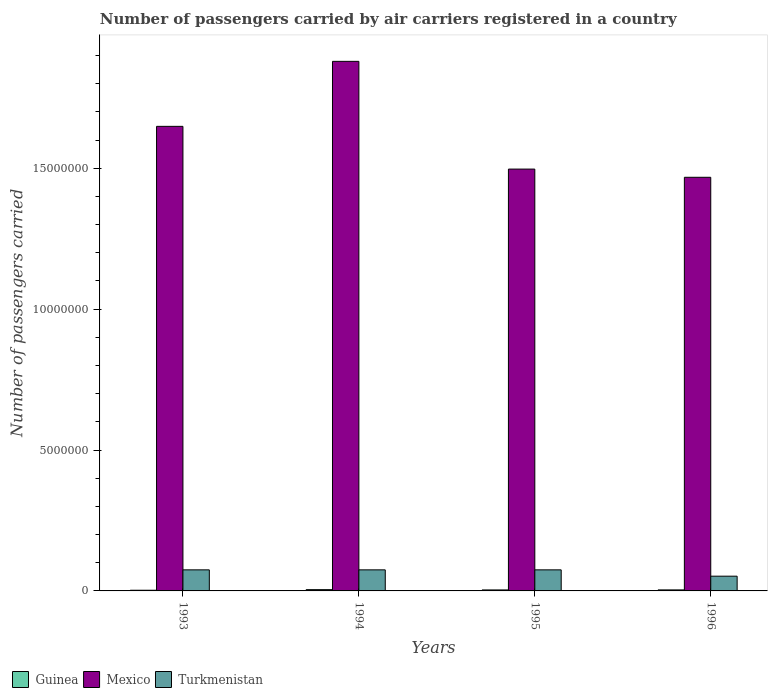Are the number of bars per tick equal to the number of legend labels?
Make the answer very short. Yes. How many bars are there on the 2nd tick from the right?
Offer a very short reply. 3. What is the label of the 3rd group of bars from the left?
Your answer should be very brief. 1995. In how many cases, is the number of bars for a given year not equal to the number of legend labels?
Your answer should be very brief. 0. What is the number of passengers carried by air carriers in Turkmenistan in 1995?
Offer a terse response. 7.48e+05. Across all years, what is the maximum number of passengers carried by air carriers in Guinea?
Your response must be concise. 4.50e+04. Across all years, what is the minimum number of passengers carried by air carriers in Turkmenistan?
Make the answer very short. 5.23e+05. In which year was the number of passengers carried by air carriers in Guinea minimum?
Offer a very short reply. 1993. What is the total number of passengers carried by air carriers in Turkmenistan in the graph?
Offer a terse response. 2.77e+06. What is the difference between the number of passengers carried by air carriers in Guinea in 1993 and that in 1995?
Your answer should be compact. -1.08e+04. What is the difference between the number of passengers carried by air carriers in Mexico in 1993 and the number of passengers carried by air carriers in Turkmenistan in 1995?
Your response must be concise. 1.57e+07. What is the average number of passengers carried by air carriers in Turkmenistan per year?
Keep it short and to the point. 6.92e+05. In the year 1996, what is the difference between the number of passengers carried by air carriers in Mexico and number of passengers carried by air carriers in Turkmenistan?
Your answer should be compact. 1.42e+07. In how many years, is the number of passengers carried by air carriers in Turkmenistan greater than 4000000?
Make the answer very short. 0. What is the ratio of the number of passengers carried by air carriers in Guinea in 1993 to that in 1995?
Offer a very short reply. 0.69. What is the difference between the highest and the second highest number of passengers carried by air carriers in Guinea?
Make the answer very short. 8700. What is the difference between the highest and the lowest number of passengers carried by air carriers in Mexico?
Provide a short and direct response. 4.11e+06. Is the sum of the number of passengers carried by air carriers in Turkmenistan in 1994 and 1996 greater than the maximum number of passengers carried by air carriers in Mexico across all years?
Provide a short and direct response. No. What does the 3rd bar from the left in 1996 represents?
Provide a succinct answer. Turkmenistan. What does the 2nd bar from the right in 1996 represents?
Make the answer very short. Mexico. How many bars are there?
Your answer should be very brief. 12. Are all the bars in the graph horizontal?
Keep it short and to the point. No. How many years are there in the graph?
Keep it short and to the point. 4. What is the difference between two consecutive major ticks on the Y-axis?
Your response must be concise. 5.00e+06. Does the graph contain any zero values?
Provide a short and direct response. No. Does the graph contain grids?
Ensure brevity in your answer.  No. How many legend labels are there?
Your response must be concise. 3. How are the legend labels stacked?
Your response must be concise. Horizontal. What is the title of the graph?
Give a very brief answer. Number of passengers carried by air carriers registered in a country. What is the label or title of the Y-axis?
Ensure brevity in your answer.  Number of passengers carried. What is the Number of passengers carried of Guinea in 1993?
Ensure brevity in your answer.  2.42e+04. What is the Number of passengers carried in Mexico in 1993?
Provide a short and direct response. 1.65e+07. What is the Number of passengers carried in Turkmenistan in 1993?
Give a very brief answer. 7.48e+05. What is the Number of passengers carried of Guinea in 1994?
Your answer should be very brief. 4.50e+04. What is the Number of passengers carried in Mexico in 1994?
Your answer should be compact. 1.88e+07. What is the Number of passengers carried of Turkmenistan in 1994?
Provide a short and direct response. 7.48e+05. What is the Number of passengers carried in Guinea in 1995?
Ensure brevity in your answer.  3.50e+04. What is the Number of passengers carried of Mexico in 1995?
Offer a very short reply. 1.50e+07. What is the Number of passengers carried of Turkmenistan in 1995?
Provide a succinct answer. 7.48e+05. What is the Number of passengers carried in Guinea in 1996?
Ensure brevity in your answer.  3.63e+04. What is the Number of passengers carried in Mexico in 1996?
Ensure brevity in your answer.  1.47e+07. What is the Number of passengers carried of Turkmenistan in 1996?
Your answer should be compact. 5.23e+05. Across all years, what is the maximum Number of passengers carried of Guinea?
Provide a succinct answer. 4.50e+04. Across all years, what is the maximum Number of passengers carried in Mexico?
Keep it short and to the point. 1.88e+07. Across all years, what is the maximum Number of passengers carried of Turkmenistan?
Your answer should be compact. 7.48e+05. Across all years, what is the minimum Number of passengers carried in Guinea?
Make the answer very short. 2.42e+04. Across all years, what is the minimum Number of passengers carried of Mexico?
Provide a short and direct response. 1.47e+07. Across all years, what is the minimum Number of passengers carried in Turkmenistan?
Provide a succinct answer. 5.23e+05. What is the total Number of passengers carried of Guinea in the graph?
Provide a short and direct response. 1.40e+05. What is the total Number of passengers carried of Mexico in the graph?
Give a very brief answer. 6.49e+07. What is the total Number of passengers carried of Turkmenistan in the graph?
Your answer should be compact. 2.77e+06. What is the difference between the Number of passengers carried in Guinea in 1993 and that in 1994?
Keep it short and to the point. -2.08e+04. What is the difference between the Number of passengers carried in Mexico in 1993 and that in 1994?
Offer a terse response. -2.31e+06. What is the difference between the Number of passengers carried in Turkmenistan in 1993 and that in 1994?
Provide a short and direct response. 0. What is the difference between the Number of passengers carried of Guinea in 1993 and that in 1995?
Offer a terse response. -1.08e+04. What is the difference between the Number of passengers carried of Mexico in 1993 and that in 1995?
Provide a succinct answer. 1.52e+06. What is the difference between the Number of passengers carried in Guinea in 1993 and that in 1996?
Ensure brevity in your answer.  -1.21e+04. What is the difference between the Number of passengers carried in Mexico in 1993 and that in 1996?
Provide a short and direct response. 1.81e+06. What is the difference between the Number of passengers carried of Turkmenistan in 1993 and that in 1996?
Give a very brief answer. 2.25e+05. What is the difference between the Number of passengers carried of Guinea in 1994 and that in 1995?
Your answer should be compact. 10000. What is the difference between the Number of passengers carried of Mexico in 1994 and that in 1995?
Offer a very short reply. 3.82e+06. What is the difference between the Number of passengers carried of Turkmenistan in 1994 and that in 1995?
Give a very brief answer. 0. What is the difference between the Number of passengers carried of Guinea in 1994 and that in 1996?
Your answer should be compact. 8700. What is the difference between the Number of passengers carried in Mexico in 1994 and that in 1996?
Your answer should be compact. 4.11e+06. What is the difference between the Number of passengers carried of Turkmenistan in 1994 and that in 1996?
Your answer should be compact. 2.25e+05. What is the difference between the Number of passengers carried of Guinea in 1995 and that in 1996?
Offer a terse response. -1300. What is the difference between the Number of passengers carried in Mexico in 1995 and that in 1996?
Offer a very short reply. 2.91e+05. What is the difference between the Number of passengers carried in Turkmenistan in 1995 and that in 1996?
Ensure brevity in your answer.  2.25e+05. What is the difference between the Number of passengers carried in Guinea in 1993 and the Number of passengers carried in Mexico in 1994?
Offer a very short reply. -1.88e+07. What is the difference between the Number of passengers carried in Guinea in 1993 and the Number of passengers carried in Turkmenistan in 1994?
Offer a terse response. -7.24e+05. What is the difference between the Number of passengers carried in Mexico in 1993 and the Number of passengers carried in Turkmenistan in 1994?
Offer a terse response. 1.57e+07. What is the difference between the Number of passengers carried in Guinea in 1993 and the Number of passengers carried in Mexico in 1995?
Offer a terse response. -1.49e+07. What is the difference between the Number of passengers carried in Guinea in 1993 and the Number of passengers carried in Turkmenistan in 1995?
Ensure brevity in your answer.  -7.24e+05. What is the difference between the Number of passengers carried of Mexico in 1993 and the Number of passengers carried of Turkmenistan in 1995?
Keep it short and to the point. 1.57e+07. What is the difference between the Number of passengers carried of Guinea in 1993 and the Number of passengers carried of Mexico in 1996?
Make the answer very short. -1.47e+07. What is the difference between the Number of passengers carried in Guinea in 1993 and the Number of passengers carried in Turkmenistan in 1996?
Your answer should be very brief. -4.99e+05. What is the difference between the Number of passengers carried in Mexico in 1993 and the Number of passengers carried in Turkmenistan in 1996?
Give a very brief answer. 1.60e+07. What is the difference between the Number of passengers carried in Guinea in 1994 and the Number of passengers carried in Mexico in 1995?
Your response must be concise. -1.49e+07. What is the difference between the Number of passengers carried in Guinea in 1994 and the Number of passengers carried in Turkmenistan in 1995?
Give a very brief answer. -7.03e+05. What is the difference between the Number of passengers carried of Mexico in 1994 and the Number of passengers carried of Turkmenistan in 1995?
Offer a very short reply. 1.80e+07. What is the difference between the Number of passengers carried of Guinea in 1994 and the Number of passengers carried of Mexico in 1996?
Ensure brevity in your answer.  -1.46e+07. What is the difference between the Number of passengers carried in Guinea in 1994 and the Number of passengers carried in Turkmenistan in 1996?
Make the answer very short. -4.78e+05. What is the difference between the Number of passengers carried of Mexico in 1994 and the Number of passengers carried of Turkmenistan in 1996?
Provide a succinct answer. 1.83e+07. What is the difference between the Number of passengers carried of Guinea in 1995 and the Number of passengers carried of Mexico in 1996?
Give a very brief answer. -1.46e+07. What is the difference between the Number of passengers carried of Guinea in 1995 and the Number of passengers carried of Turkmenistan in 1996?
Keep it short and to the point. -4.88e+05. What is the difference between the Number of passengers carried of Mexico in 1995 and the Number of passengers carried of Turkmenistan in 1996?
Your response must be concise. 1.44e+07. What is the average Number of passengers carried in Guinea per year?
Keep it short and to the point. 3.51e+04. What is the average Number of passengers carried of Mexico per year?
Offer a very short reply. 1.62e+07. What is the average Number of passengers carried in Turkmenistan per year?
Offer a very short reply. 6.92e+05. In the year 1993, what is the difference between the Number of passengers carried of Guinea and Number of passengers carried of Mexico?
Provide a short and direct response. -1.65e+07. In the year 1993, what is the difference between the Number of passengers carried in Guinea and Number of passengers carried in Turkmenistan?
Your response must be concise. -7.24e+05. In the year 1993, what is the difference between the Number of passengers carried of Mexico and Number of passengers carried of Turkmenistan?
Keep it short and to the point. 1.57e+07. In the year 1994, what is the difference between the Number of passengers carried in Guinea and Number of passengers carried in Mexico?
Provide a short and direct response. -1.87e+07. In the year 1994, what is the difference between the Number of passengers carried in Guinea and Number of passengers carried in Turkmenistan?
Ensure brevity in your answer.  -7.03e+05. In the year 1994, what is the difference between the Number of passengers carried in Mexico and Number of passengers carried in Turkmenistan?
Your answer should be very brief. 1.80e+07. In the year 1995, what is the difference between the Number of passengers carried of Guinea and Number of passengers carried of Mexico?
Ensure brevity in your answer.  -1.49e+07. In the year 1995, what is the difference between the Number of passengers carried of Guinea and Number of passengers carried of Turkmenistan?
Provide a succinct answer. -7.13e+05. In the year 1995, what is the difference between the Number of passengers carried in Mexico and Number of passengers carried in Turkmenistan?
Your answer should be very brief. 1.42e+07. In the year 1996, what is the difference between the Number of passengers carried of Guinea and Number of passengers carried of Mexico?
Your answer should be compact. -1.46e+07. In the year 1996, what is the difference between the Number of passengers carried in Guinea and Number of passengers carried in Turkmenistan?
Your answer should be compact. -4.87e+05. In the year 1996, what is the difference between the Number of passengers carried in Mexico and Number of passengers carried in Turkmenistan?
Your answer should be very brief. 1.42e+07. What is the ratio of the Number of passengers carried of Guinea in 1993 to that in 1994?
Ensure brevity in your answer.  0.54. What is the ratio of the Number of passengers carried in Mexico in 1993 to that in 1994?
Offer a terse response. 0.88. What is the ratio of the Number of passengers carried in Turkmenistan in 1993 to that in 1994?
Your answer should be very brief. 1. What is the ratio of the Number of passengers carried of Guinea in 1993 to that in 1995?
Offer a very short reply. 0.69. What is the ratio of the Number of passengers carried of Mexico in 1993 to that in 1995?
Your answer should be very brief. 1.1. What is the ratio of the Number of passengers carried in Turkmenistan in 1993 to that in 1995?
Keep it short and to the point. 1. What is the ratio of the Number of passengers carried of Guinea in 1993 to that in 1996?
Your answer should be very brief. 0.67. What is the ratio of the Number of passengers carried in Mexico in 1993 to that in 1996?
Keep it short and to the point. 1.12. What is the ratio of the Number of passengers carried of Turkmenistan in 1993 to that in 1996?
Your answer should be very brief. 1.43. What is the ratio of the Number of passengers carried in Mexico in 1994 to that in 1995?
Offer a very short reply. 1.26. What is the ratio of the Number of passengers carried of Turkmenistan in 1994 to that in 1995?
Your answer should be very brief. 1. What is the ratio of the Number of passengers carried of Guinea in 1994 to that in 1996?
Offer a terse response. 1.24. What is the ratio of the Number of passengers carried of Mexico in 1994 to that in 1996?
Your answer should be very brief. 1.28. What is the ratio of the Number of passengers carried in Turkmenistan in 1994 to that in 1996?
Your answer should be very brief. 1.43. What is the ratio of the Number of passengers carried of Guinea in 1995 to that in 1996?
Your answer should be compact. 0.96. What is the ratio of the Number of passengers carried of Mexico in 1995 to that in 1996?
Keep it short and to the point. 1.02. What is the ratio of the Number of passengers carried of Turkmenistan in 1995 to that in 1996?
Ensure brevity in your answer.  1.43. What is the difference between the highest and the second highest Number of passengers carried in Guinea?
Your answer should be very brief. 8700. What is the difference between the highest and the second highest Number of passengers carried of Mexico?
Your response must be concise. 2.31e+06. What is the difference between the highest and the second highest Number of passengers carried of Turkmenistan?
Offer a very short reply. 0. What is the difference between the highest and the lowest Number of passengers carried of Guinea?
Keep it short and to the point. 2.08e+04. What is the difference between the highest and the lowest Number of passengers carried in Mexico?
Make the answer very short. 4.11e+06. What is the difference between the highest and the lowest Number of passengers carried of Turkmenistan?
Your answer should be very brief. 2.25e+05. 